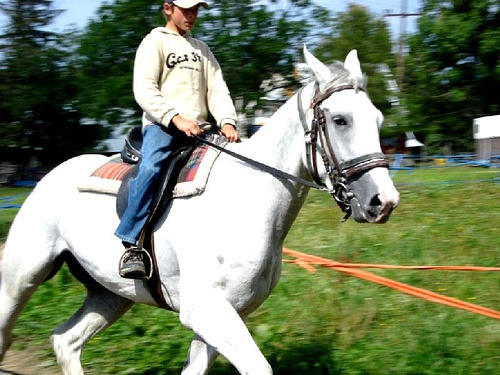Describe the objects in this image and their specific colors. I can see horse in lightblue, white, black, gray, and darkgray tones and people in lightblue, ivory, black, darkgray, and tan tones in this image. 